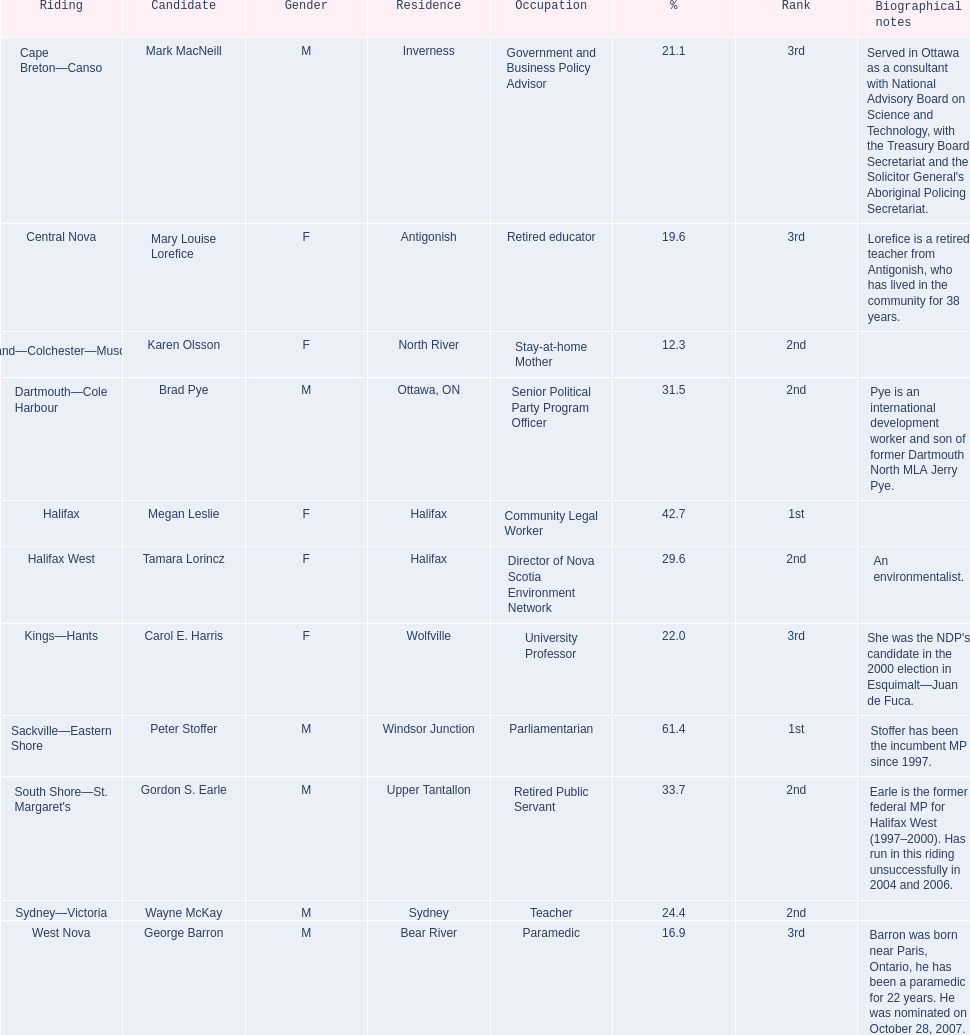Tell me the total number of votes the female candidates got. 52,277. 